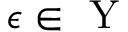Convert formula to latex. <formula><loc_0><loc_0><loc_500><loc_500>\epsilon \in Y</formula> 